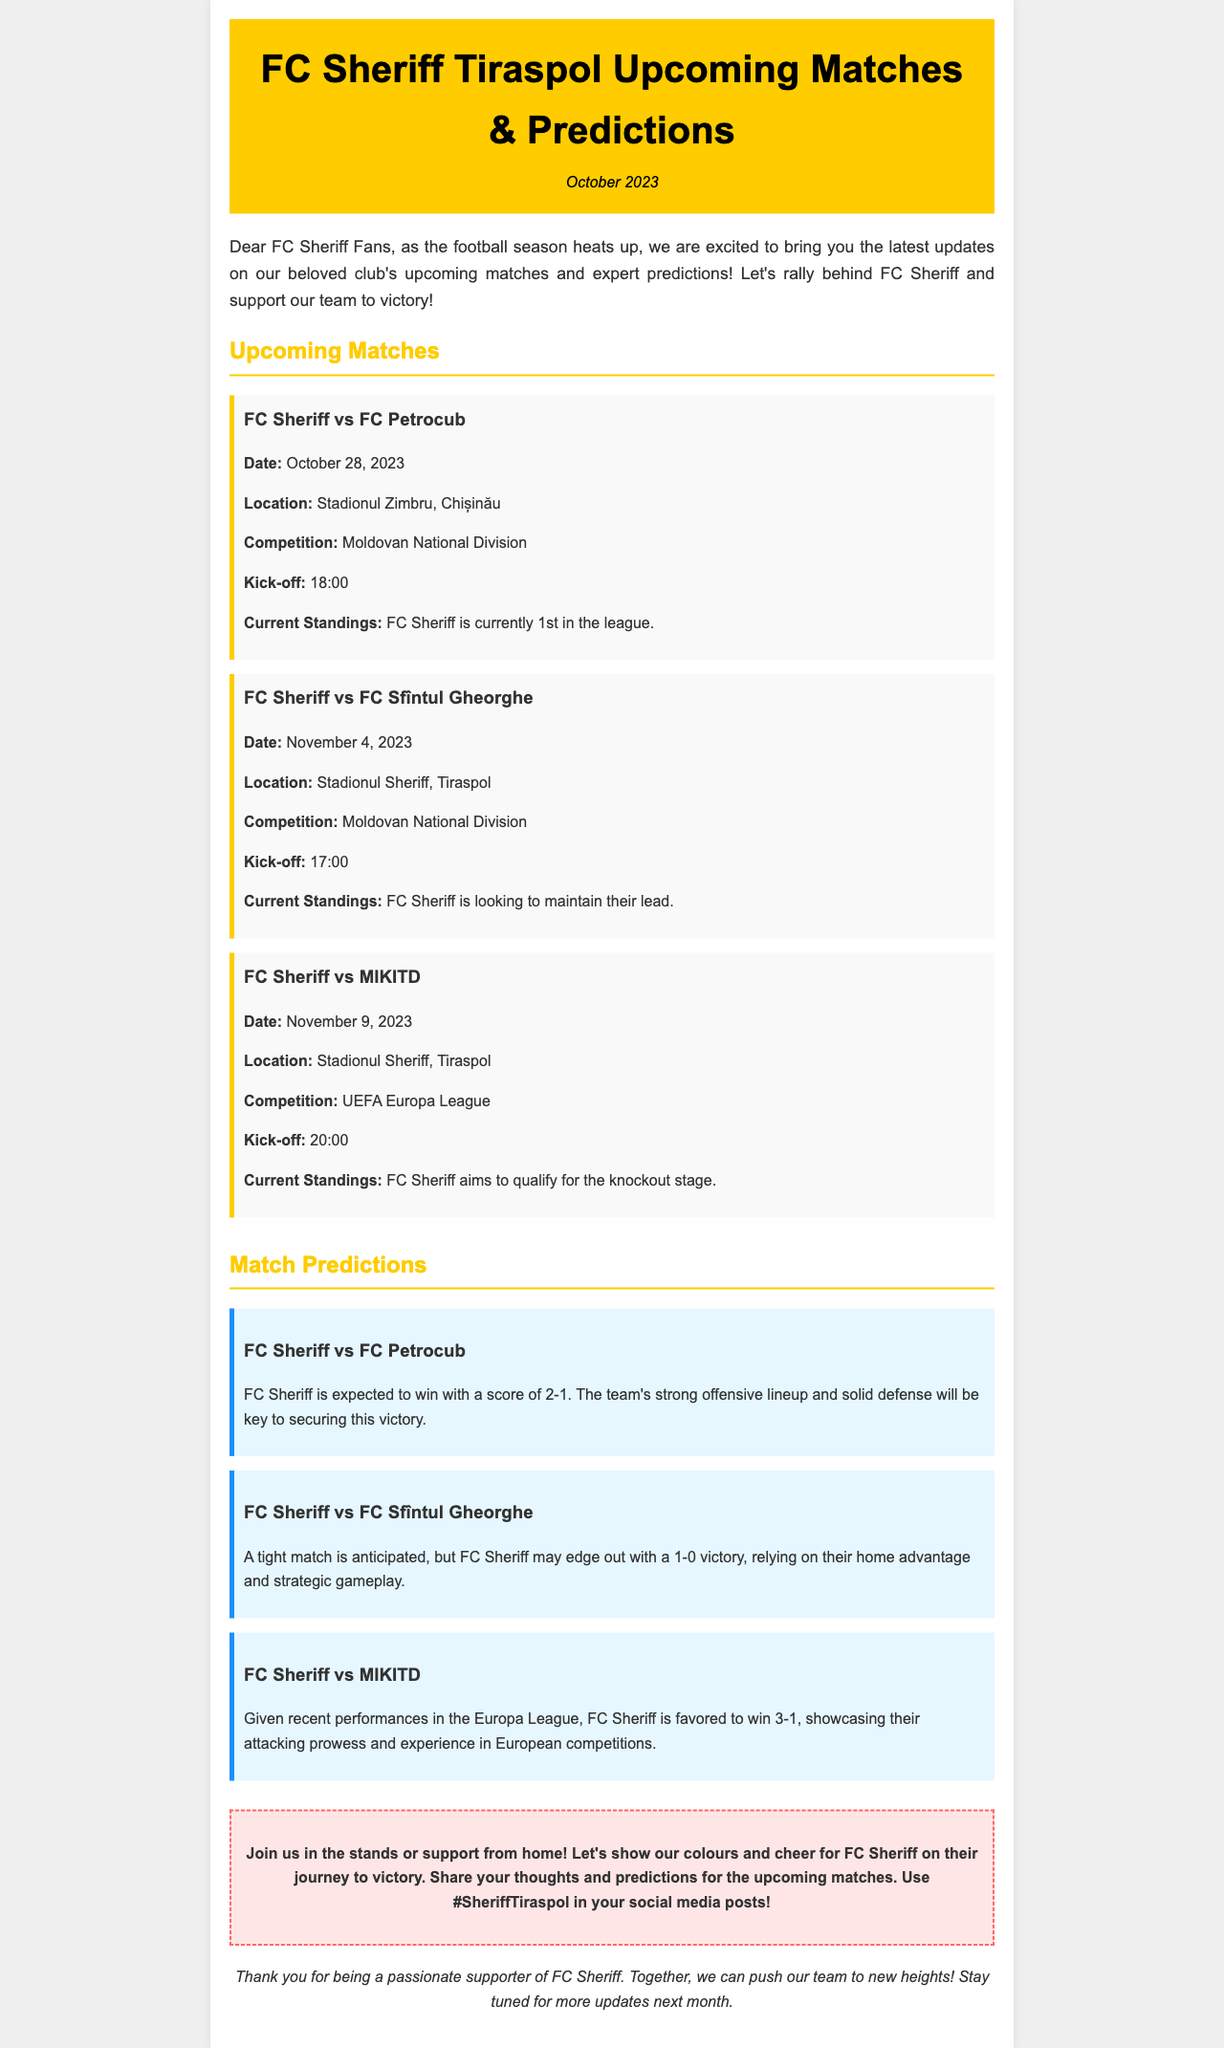What is the date of the match against FC Petrocub? The document states that the match against FC Petrocub is scheduled for October 28, 2023.
Answer: October 28, 2023 Where will the match against FC Sfîntul Gheorghe be held? According to the document, the match against FC Sfîntul Gheorghe will take place at Stadionul Sheriff, Tiraspol.
Answer: Stadionul Sheriff, Tiraspol What is FC Sheriff's current position in the league? The document mentions that FC Sheriff is currently 1st in the league.
Answer: 1st What is the predicted score for the match against MIKITD? The document forecasts a score of 3-1 for the match against MIKITD.
Answer: 3-1 Which competition will FC Sheriff face MIKITD in? The document indicates that the match against MIKITD is part of the UEFA Europa League.
Answer: UEFA Europa League What time does the match on November 4 start? The document specifies that the match on November 4 starts at 17:00.
Answer: 17:00 What is the predicted outcome for the match against FC Petrocub? The document predicts that FC Sheriff is expected to win with a score of 2-1.
Answer: 2-1 What encouragement is given to fans? The document encourages fans to join in the stands or support from home and use #SheriffTiraspol on social media.
Answer: Join us in the stands or support from home! 